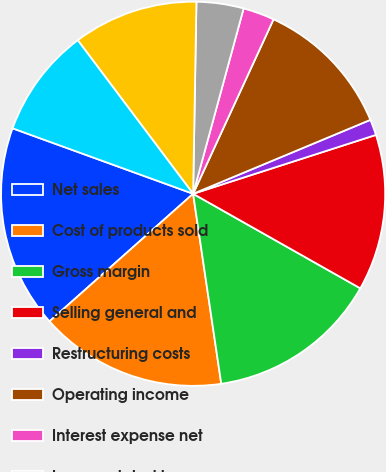<chart> <loc_0><loc_0><loc_500><loc_500><pie_chart><fcel>Net sales<fcel>Cost of products sold<fcel>Gross margin<fcel>Selling general and<fcel>Restructuring costs<fcel>Operating income<fcel>Interest expense net<fcel>Losses related to<fcel>Net nonoperating expenses<fcel>Income before income taxes<nl><fcel>17.1%<fcel>15.78%<fcel>14.47%<fcel>13.15%<fcel>1.33%<fcel>11.84%<fcel>2.64%<fcel>3.96%<fcel>10.53%<fcel>9.21%<nl></chart> 